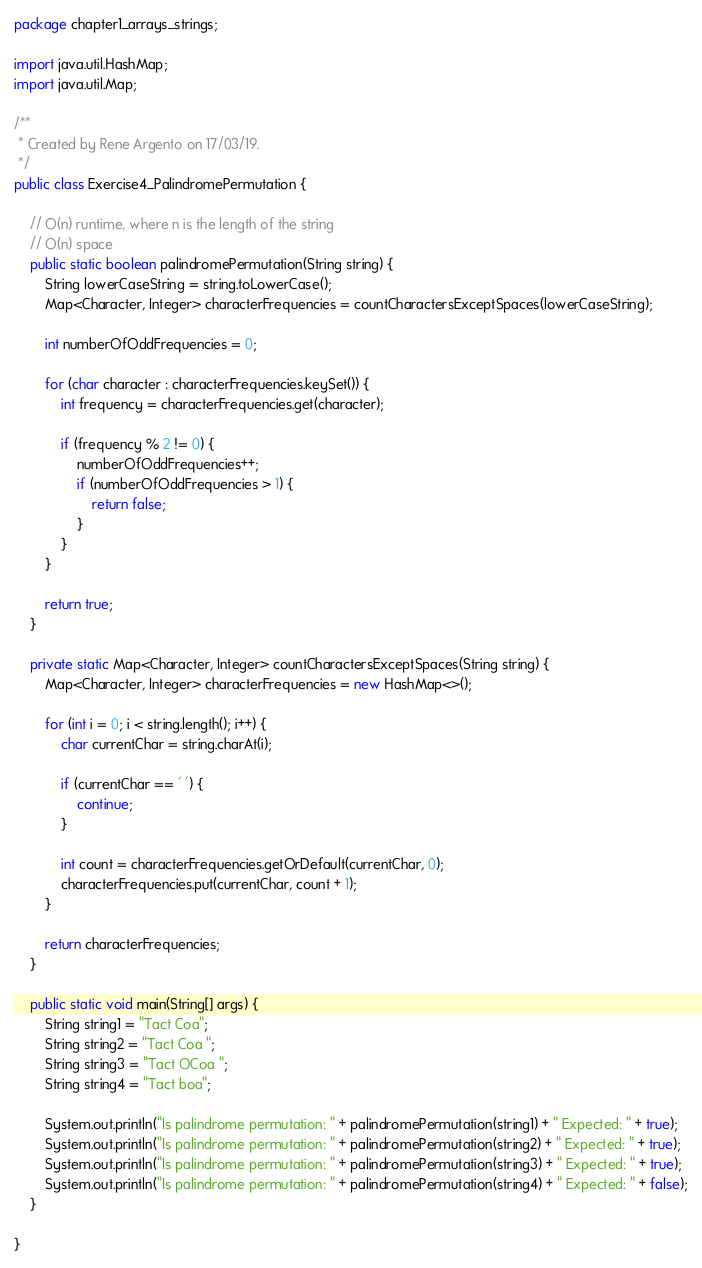<code> <loc_0><loc_0><loc_500><loc_500><_Java_>package chapter1_arrays_strings;

import java.util.HashMap;
import java.util.Map;

/**
 * Created by Rene Argento on 17/03/19.
 */
public class Exercise4_PalindromePermutation {

    // O(n) runtime, where n is the length of the string
    // O(n) space
    public static boolean palindromePermutation(String string) {
        String lowerCaseString = string.toLowerCase();
        Map<Character, Integer> characterFrequencies = countCharactersExceptSpaces(lowerCaseString);

        int numberOfOddFrequencies = 0;

        for (char character : characterFrequencies.keySet()) {
            int frequency = characterFrequencies.get(character);

            if (frequency % 2 != 0) {
                numberOfOddFrequencies++;
                if (numberOfOddFrequencies > 1) {
                    return false;
                }
            }
        }

        return true;
    }

    private static Map<Character, Integer> countCharactersExceptSpaces(String string) {
        Map<Character, Integer> characterFrequencies = new HashMap<>();

        for (int i = 0; i < string.length(); i++) {
            char currentChar = string.charAt(i);

            if (currentChar == ' ') {
                continue;
            }

            int count = characterFrequencies.getOrDefault(currentChar, 0);
            characterFrequencies.put(currentChar, count + 1);
        }

        return characterFrequencies;
    }

    public static void main(String[] args) {
        String string1 = "Tact Coa";
        String string2 = "Tact Coa ";
        String string3 = "Tact OCoa ";
        String string4 = "Tact boa";

        System.out.println("Is palindrome permutation: " + palindromePermutation(string1) + " Expected: " + true);
        System.out.println("Is palindrome permutation: " + palindromePermutation(string2) + " Expected: " + true);
        System.out.println("Is palindrome permutation: " + palindromePermutation(string3) + " Expected: " + true);
        System.out.println("Is palindrome permutation: " + palindromePermutation(string4) + " Expected: " + false);
    }

}
</code> 